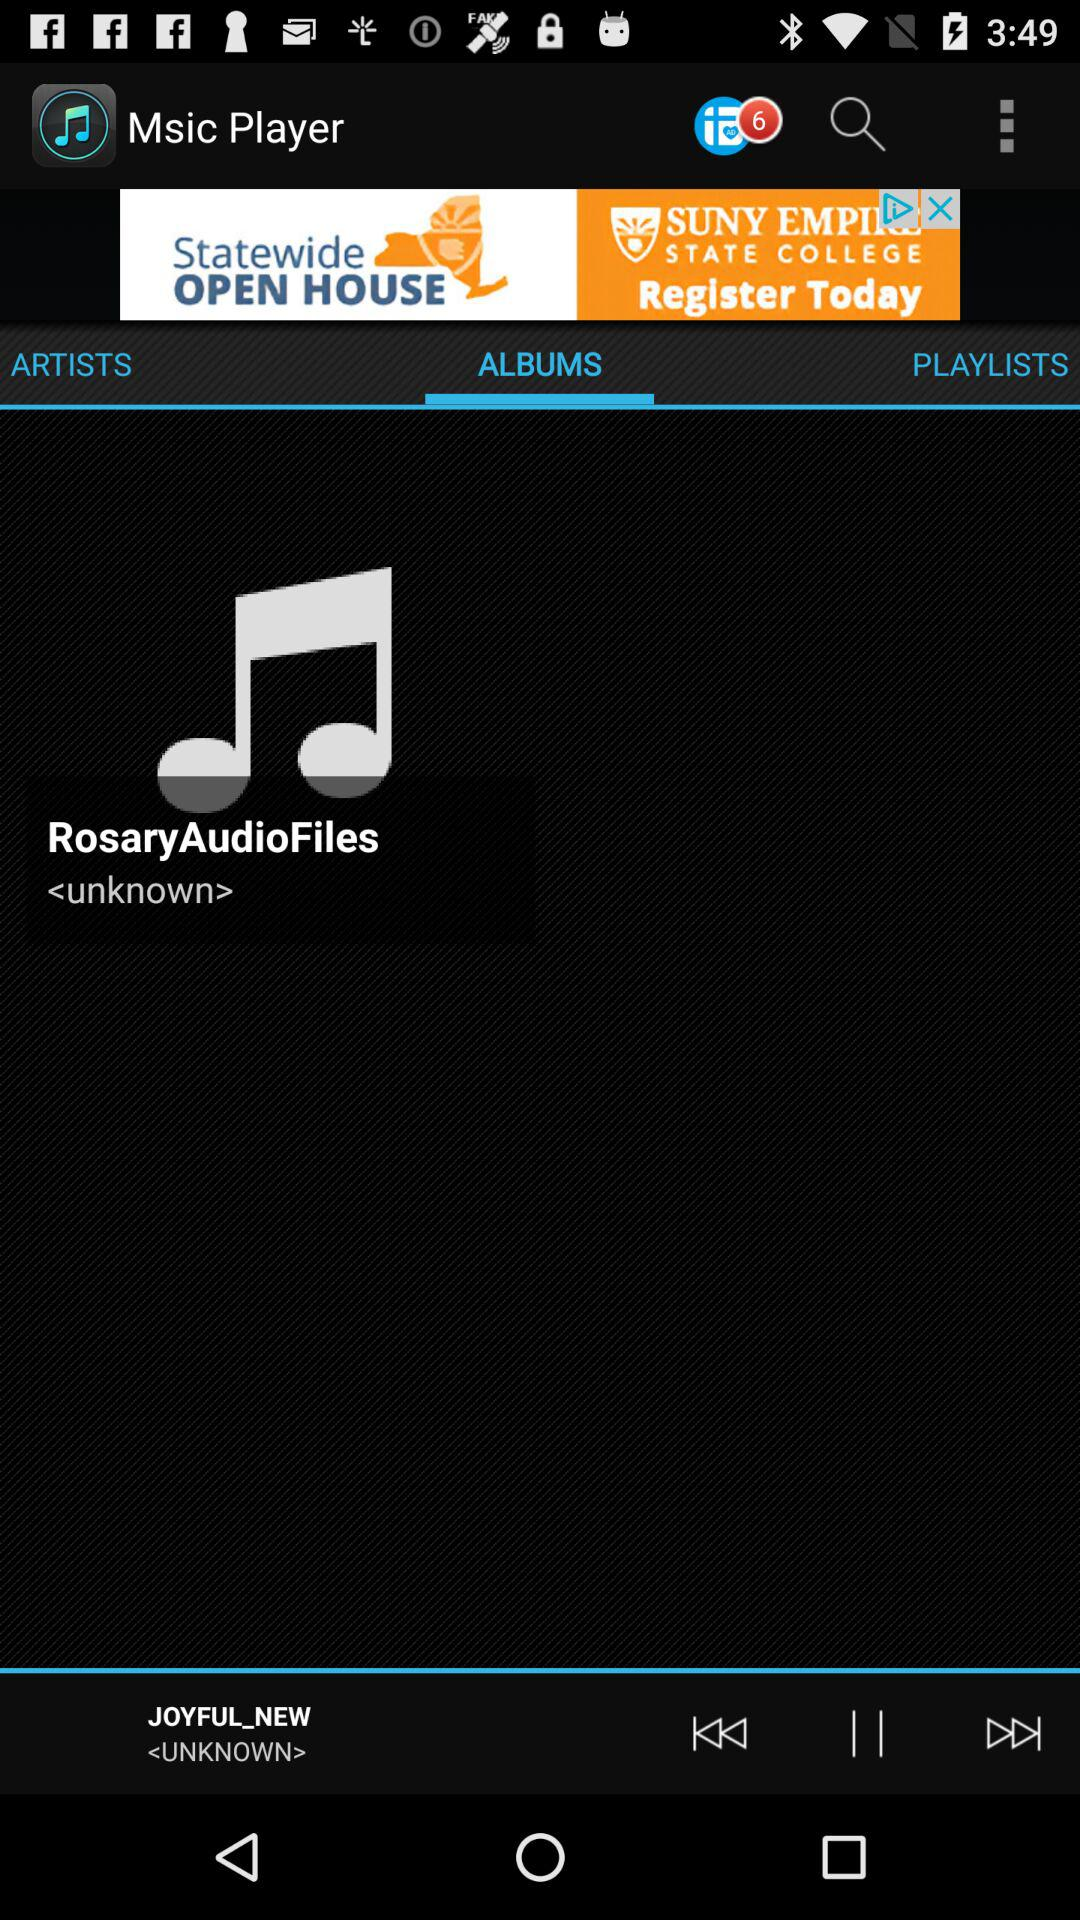How many notifications are there? There are 6 notifications. 